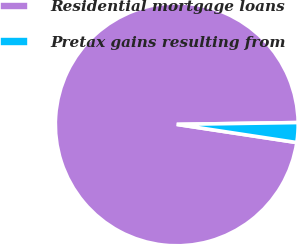Convert chart to OTSL. <chart><loc_0><loc_0><loc_500><loc_500><pie_chart><fcel>Residential mortgage loans<fcel>Pretax gains resulting from<nl><fcel>97.37%<fcel>2.63%<nl></chart> 